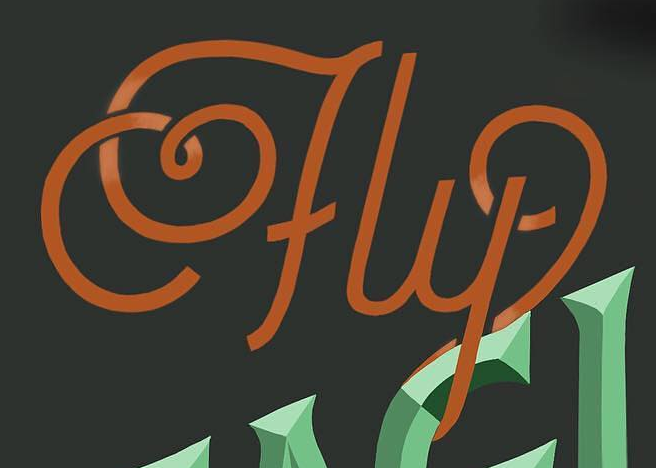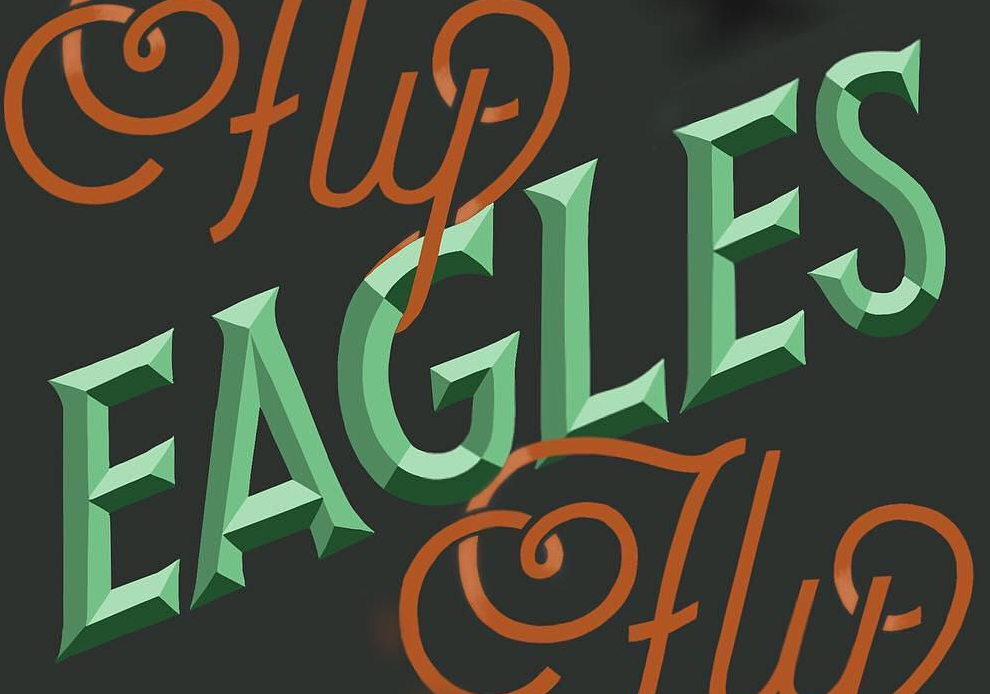What words are shown in these images in order, separated by a semicolon? fly; EAGLES 